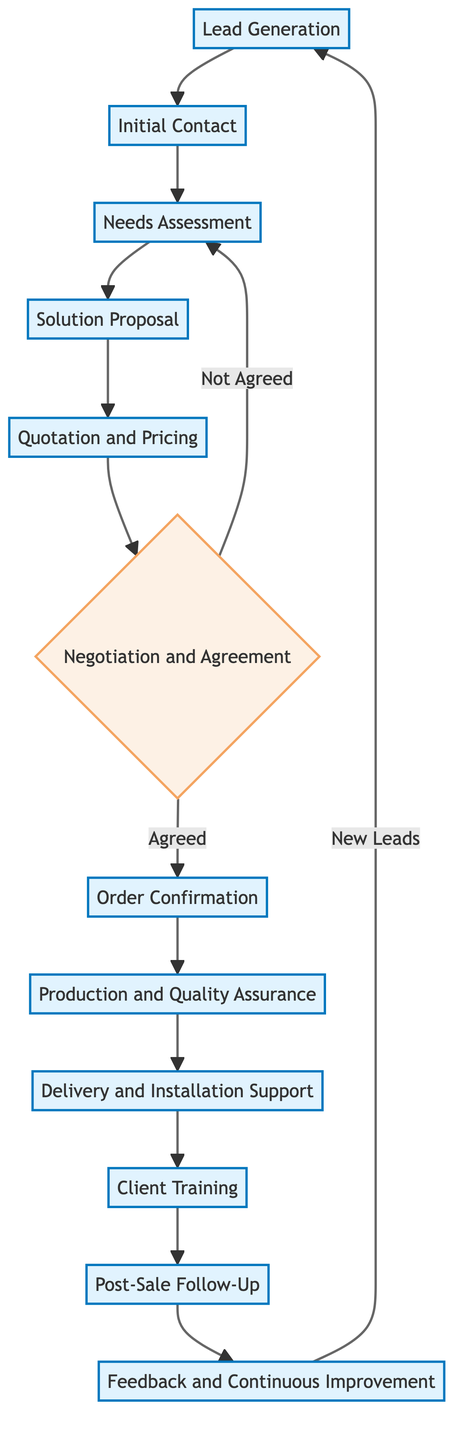What is the first step in the sales process? The first step is Lead Generation, which is where potential customers are identified through various methods like online research, industry events, and referrals.
Answer: Lead Generation How many steps are there before the Order Confirmation? The steps before Order Confirmation are Lead Generation, Initial Contact, Needs Assessment, Solution Proposal, Quotation and Pricing, and Negotiation and Agreement, totaling six steps.
Answer: Six What happens if the negotiation is not agreed upon? If the negotiation is not agreed upon, the flow returns to the Needs Assessment step, indicating that further engagement to understand client needs is necessary.
Answer: Needs Assessment What is the role of feedback in the sales process? Feedback from clients plays a critical role in the Continuous Improvement phase, where client insights are collected to enhance future products and services, contributing to long-term relationships.
Answer: Continuous Improvement Which step follows Delivery and Installation Support? After Delivery and Installation Support, the next step is Client Training, where training sessions are offered to ensure proper use and maintenance of the bolting solutions.
Answer: Client Training What type of node is the Negotiation and Agreement step? The Negotiation and Agreement step is a decision node, as it indicates a branching point in the process based on whether terms are agreed upon or not.
Answer: Decision Node What happens in the case of an agreed negotiation? When negotiation is agreed, the process continues to the Order Confirmation step, where the official purchase order is received and order details are confirmed with the client.
Answer: Order Confirmation How does the sales process incorporate new leads? New leads are generated from the Feedback and Continuous Improvement step, suggesting that satisfied clients may provide referrals or express future needs, leading back to the Lead Generation stage.
Answer: Lead Generation 